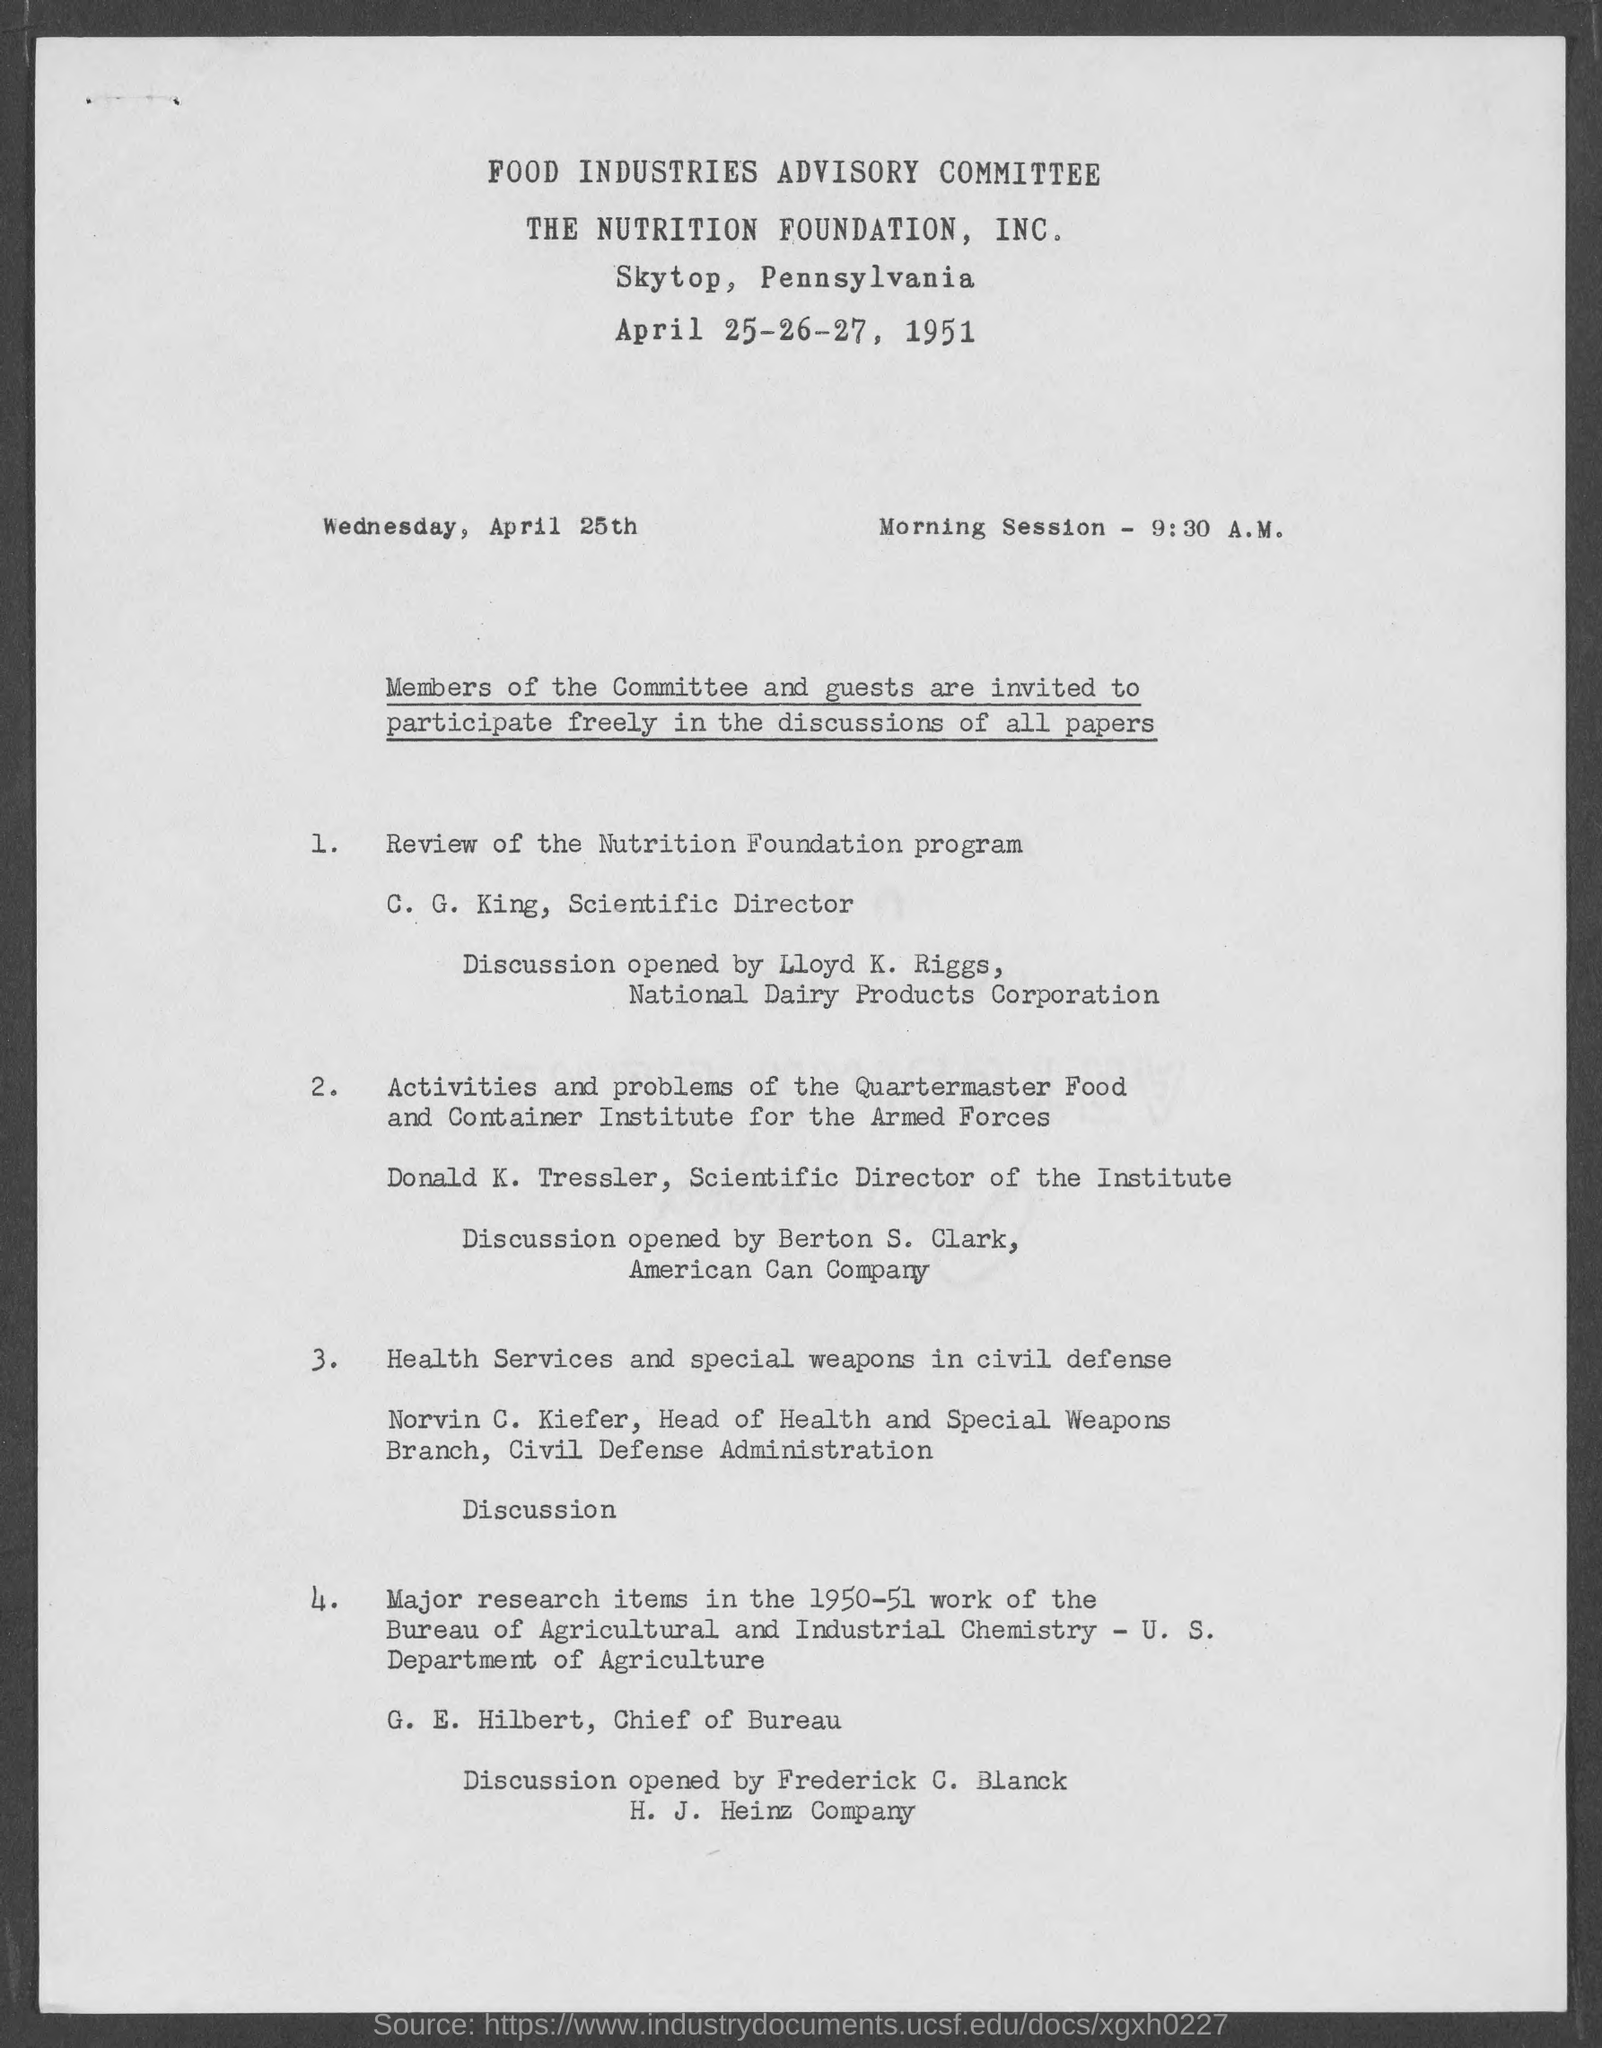Which committee is mentioned?
Your answer should be very brief. FOOD INDUSTRIES ADVISORY COMMITTEE. Where is the program going to be held?
Keep it short and to the point. Skytop, Pennsylvania. At what time is the Morning Session?
Give a very brief answer. 9:30 A.M. Who is talking about the review of the Nutrition Foundation program?
Give a very brief answer. C. G. King. What is Norvin C. Kiefer's topic?
Keep it short and to the point. Health Services and special weapons in civil defense. Who is Donald K. Tressler?
Offer a terse response. Scientific Director of the Institute. 